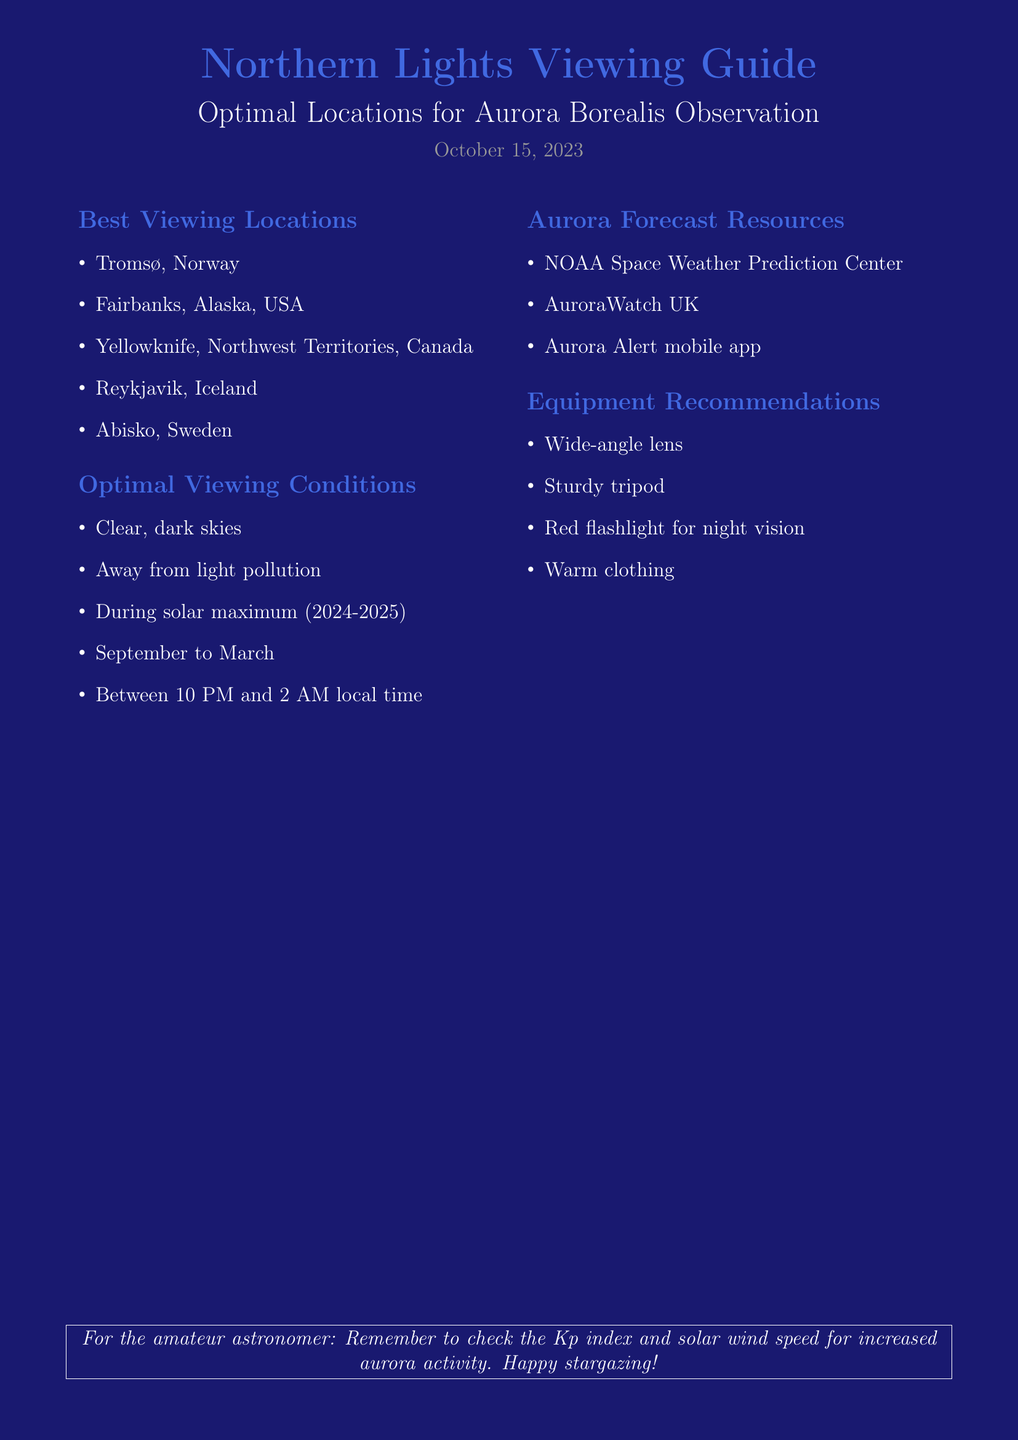What are the best viewing locations for the Northern Lights? The document lists specific locations for optimal aurora observation.
Answer: Tromsø, Norway; Fairbanks, Alaska, USA; Yellowknife, Northwest Territories, Canada; Reykjavik, Iceland; Abisko, Sweden What time of year is best for viewing auroras? The document provides specific months that are optimal for aurora observation.
Answer: September to March What is one piece of equipment recommended for aurora viewing? The document includes a list of recommended equipment for observation.
Answer: Sturdy tripod What is the date of the document? The document states the date at the top clearly.
Answer: October 15, 2023 According to the document, what must one check for increased aurora activity? The document mentions a specific index that is important for viewing conditions.
Answer: Kp index What is the optimal viewing time for auroras? The document specifies the ideal time range for aurora observation.
Answer: Between 10 PM and 2 AM local time Which app can be used for aurora monitoring? The document lists a resource for tracking auroras.
Answer: Aurora Alert mobile app What color is the background of the document? The document has a specific background color mentioned in its description.
Answer: Nightsky 